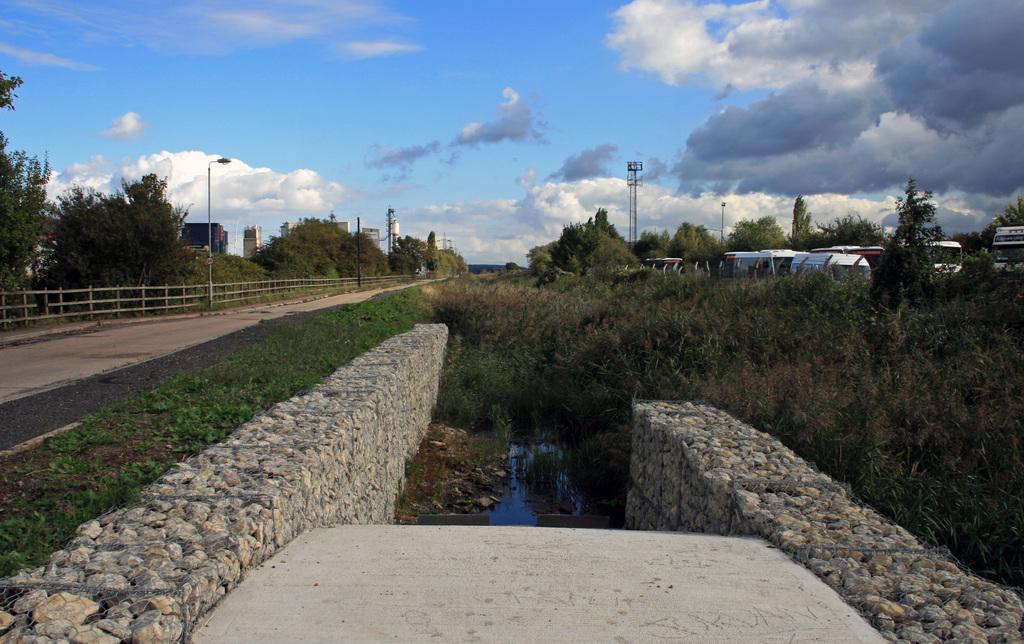How would you summarize this image in a sentence or two? In this picture I can see many trees, plants and grass. On the right I can see many buses on the road. On the left I can see the street lights, wooden fencing and roads. In the background I can see some flowers and buildings. At the top I can see the sky and clouds. At the bottom there is a water near to the wall. 